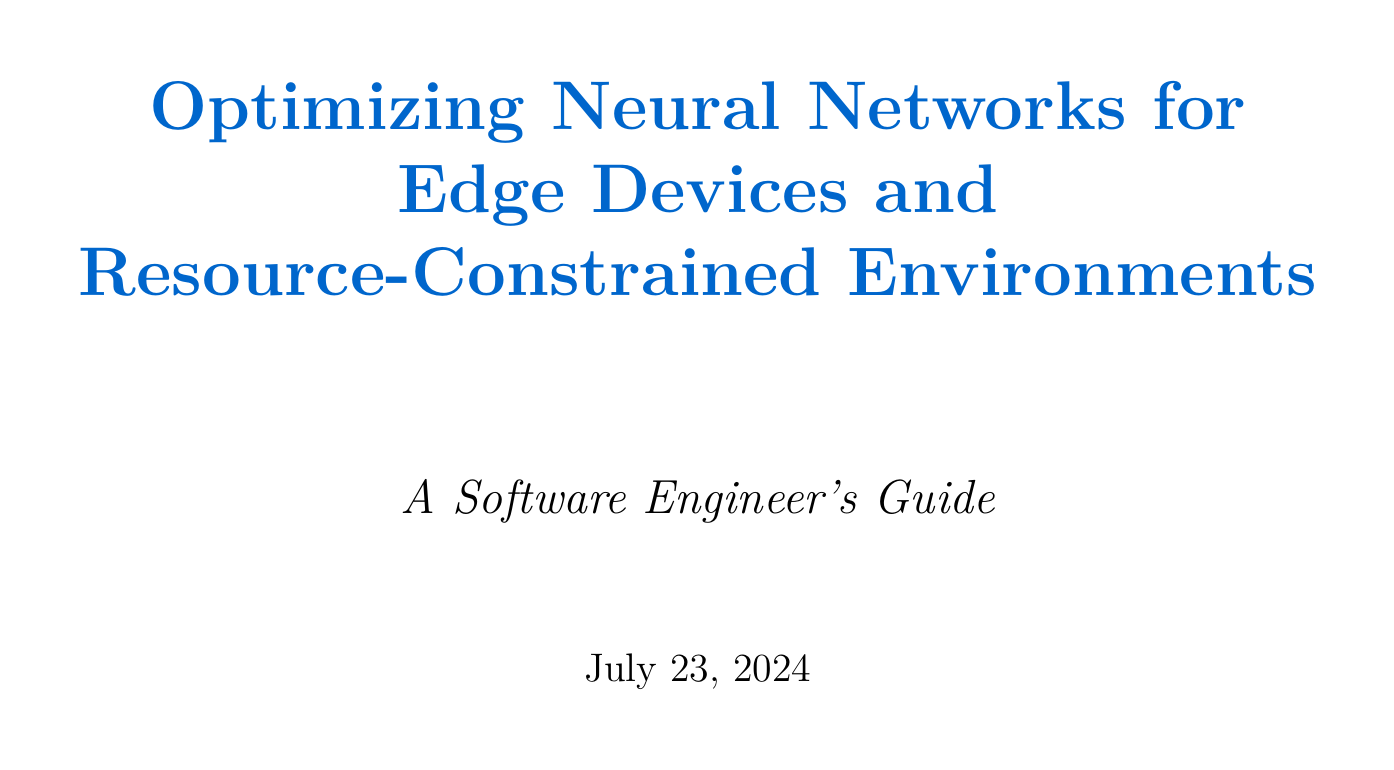What is the title of the manual? The title of the manual is stated at the beginning of the document.
Answer: Optimizing Neural Networks for Edge Devices and Resource-Constrained Environments Which technique reduces the precision of weights and activations? This technique is mentioned under model compression techniques and aims to lower the size and improve speed.
Answer: Quantization What library can be used for model versioning? The document suggests tools for managing model versions, one of which is mentioned in the deployment considerations section.
Answer: MLflow Which optimization technique involves training a smaller model? This technique is described under the model compression techniques and involves mimicry of a larger model's behavior.
Answer: Knowledge Distillation How many subsections are under Hardware-Specific Optimizations? The number of subsections can be found in the document's hardware-specific optimizations section.
Answer: Three What is the purpose of power management strategies? This concept is introduced in the deployment considerations part of the document, focusing on battery optimization.
Answer: Optimize battery life Which framework provides tools for automatic operator fusion? The document lists tools that facilitate automatic operator fusion under the memory optimization techniques section.
Answer: Apache TVM What performance profiling tool is recommended for Intel hardware? The document specifies profiling tools for different hardware, including a notable one for Intel systems.
Answer: Intel VTune Profiler What technique is suggested to reduce memory allocation overhead? This technique is mentioned under memory optimization techniques and focuses on efficient memory use.
Answer: In-place Operations 